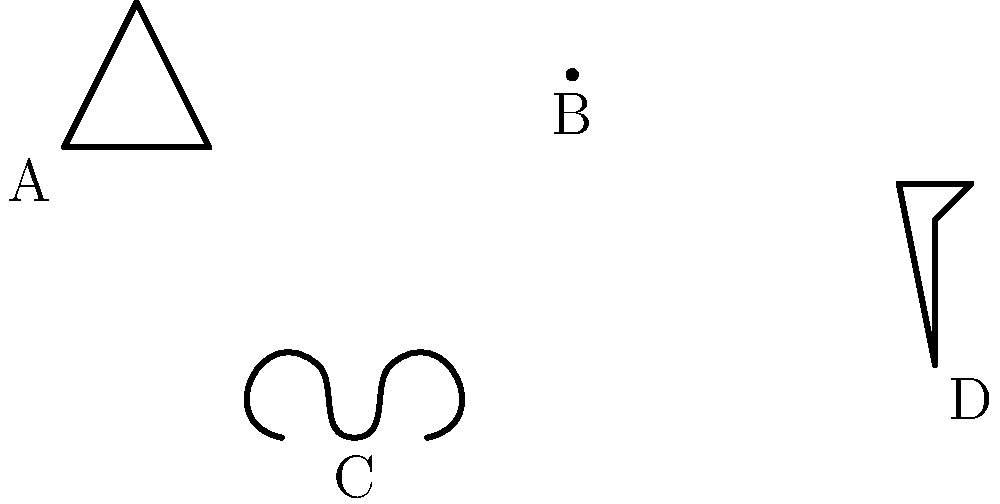Identify the fossil type represented by shape B in the diagram above. To identify the fossil type represented by shape B, let's analyze the characteristics of each shape:

1. Shape A: This triangular shape with segmented appearance is characteristic of a trilobite fossil.

2. Shape B: This is a spiral-shaped fossil with a circular form. This shape is typical of ammonites, which are extinct cephalopods with coiled shells.

3. Shape C: This symmetrical, shell-like shape with a curved profile is representative of a brachiopod fossil.

4. Shape D: This elongated shape with a stem-like structure and a crown-like top is indicative of a crinoid fossil, also known as a sea lily.

Based on these observations, shape B, with its spiral form, clearly represents an ammonite fossil.
Answer: Ammonite 